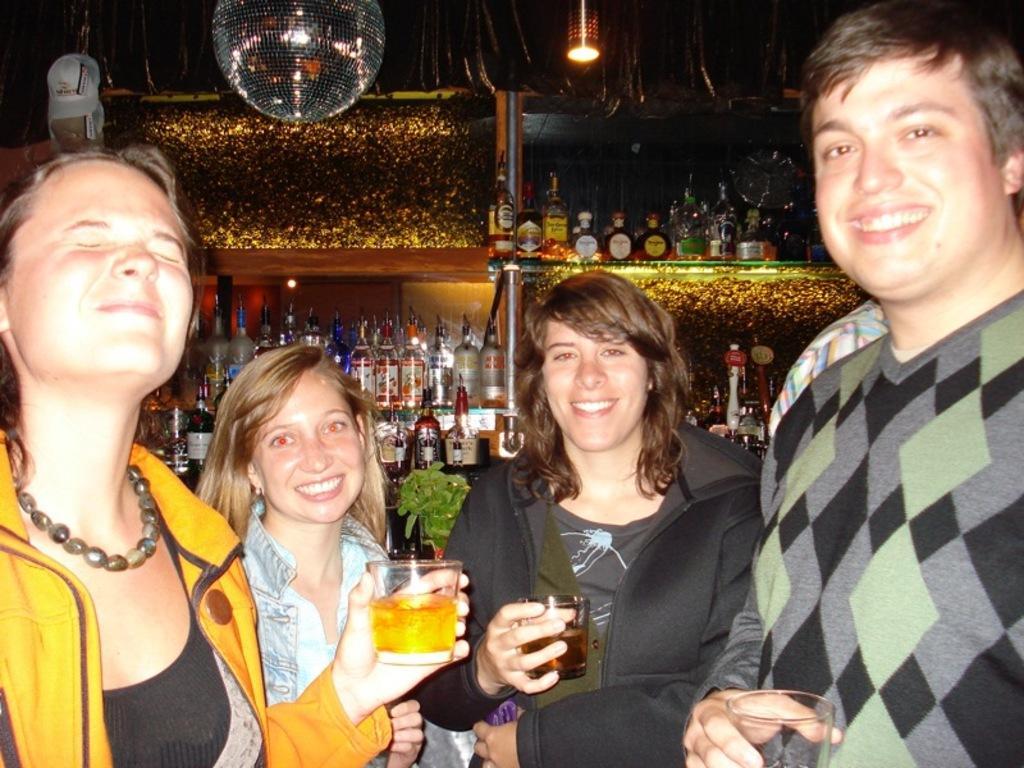Describe this image in one or two sentences. In this image we can see this people are standing and holding a glass in their hands. In the background we can see bottles and lights. 